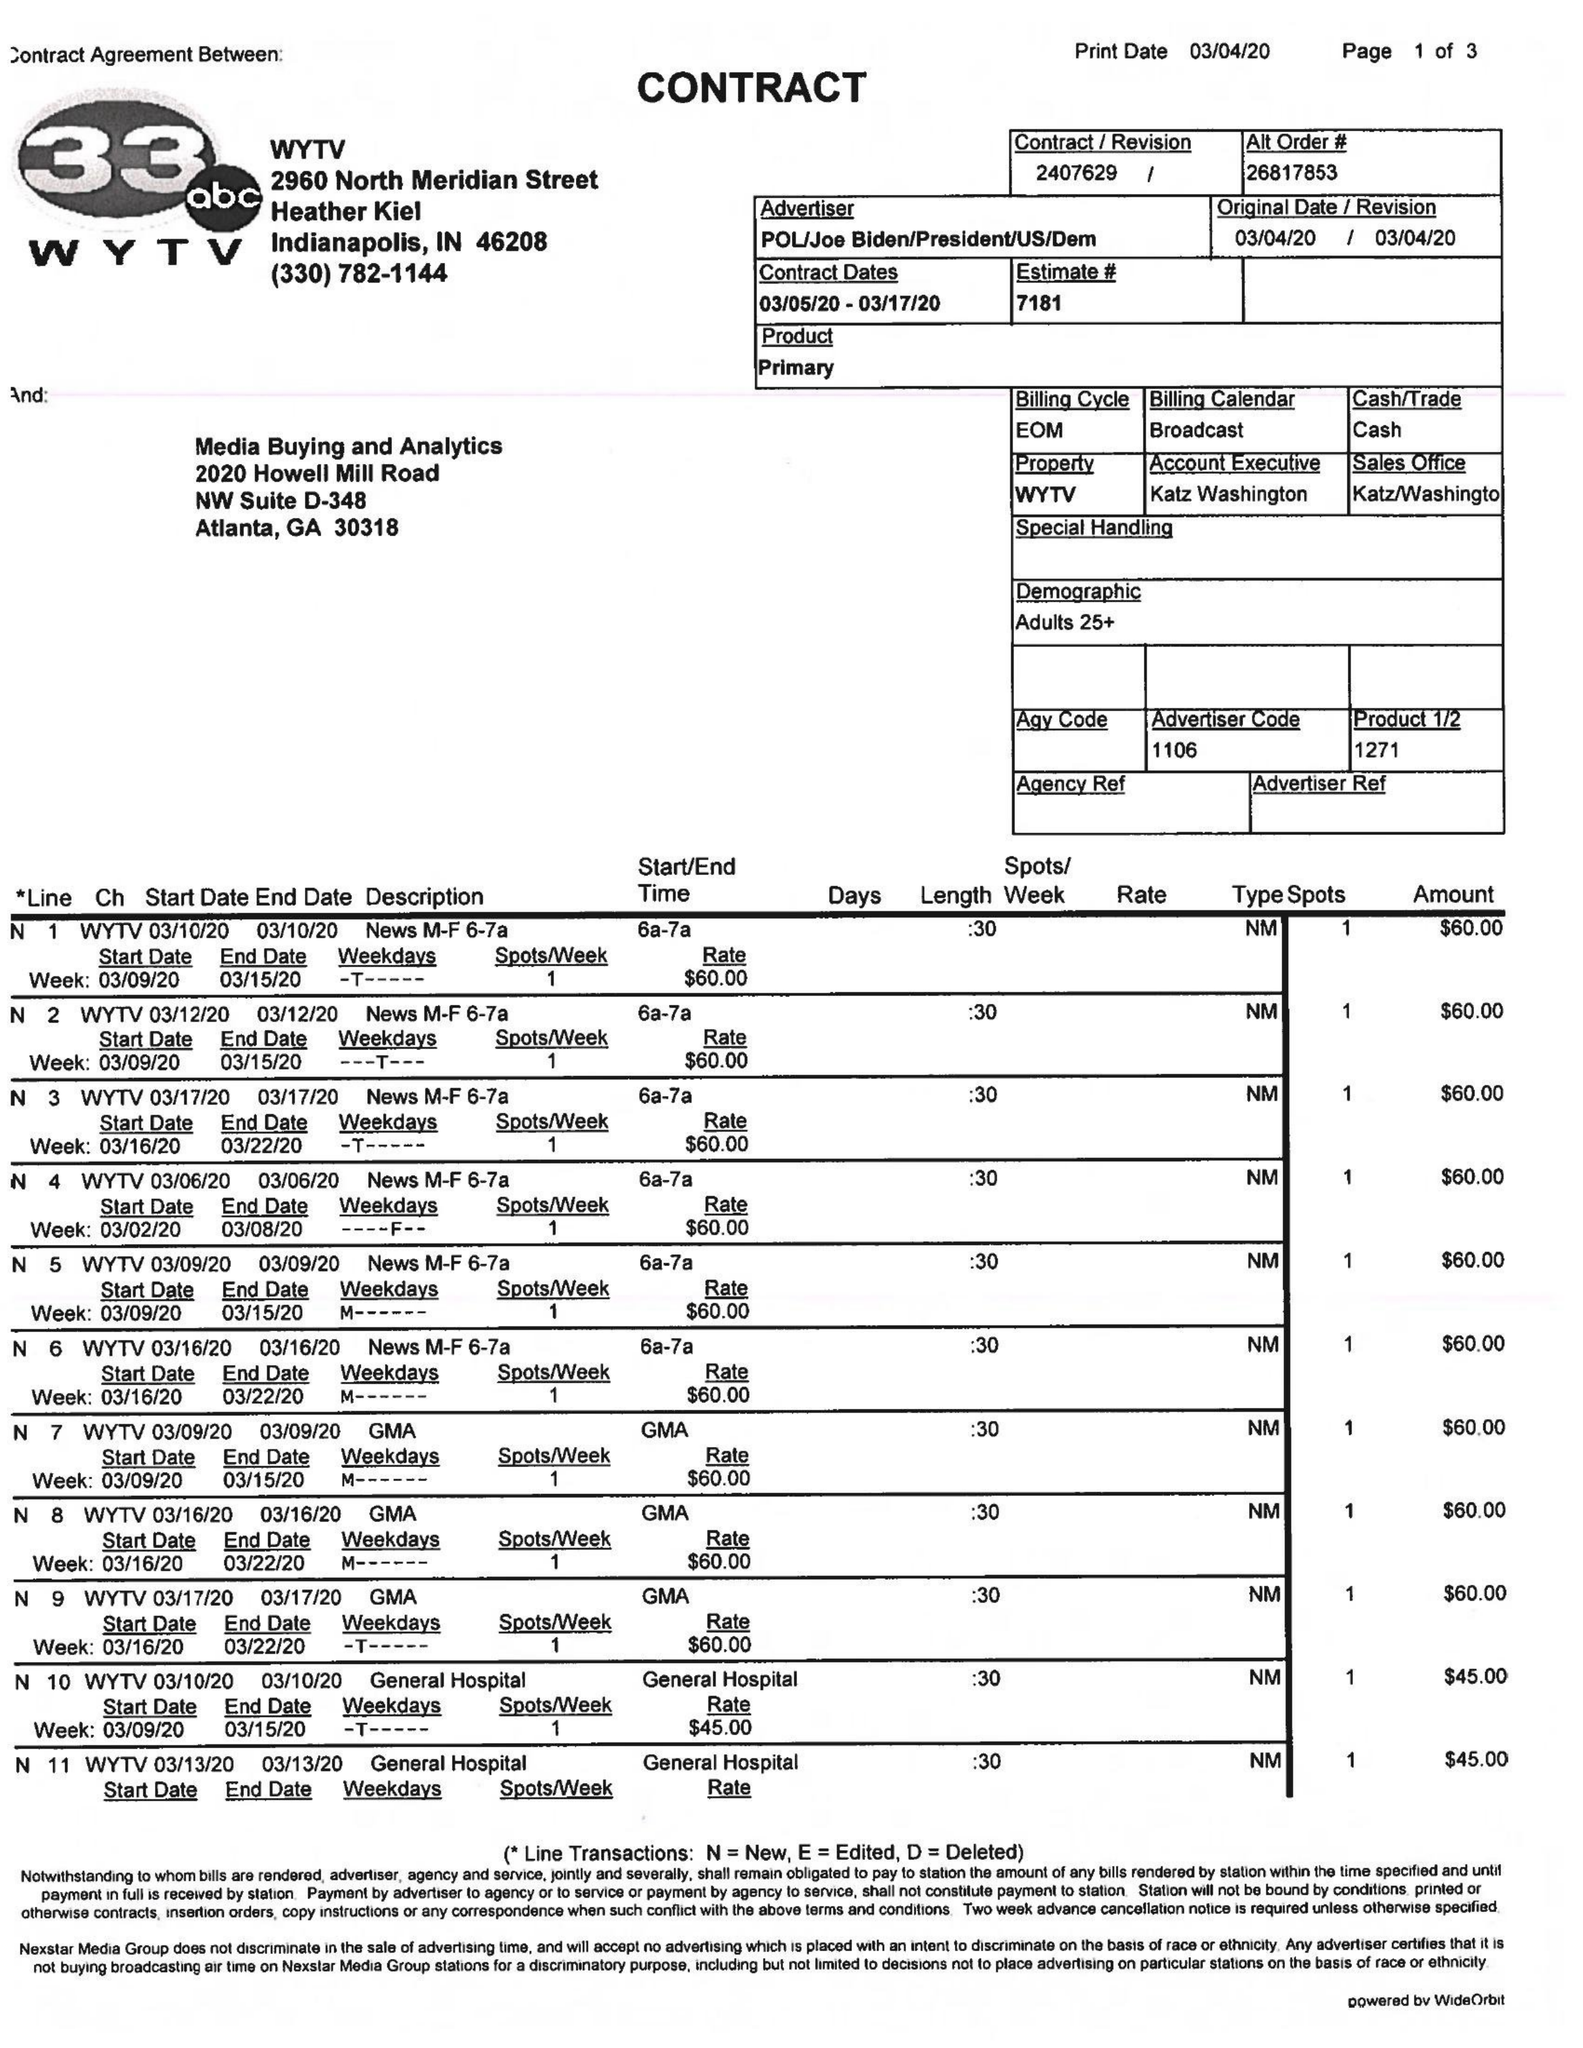What is the value for the flight_from?
Answer the question using a single word or phrase. 03/05/20 